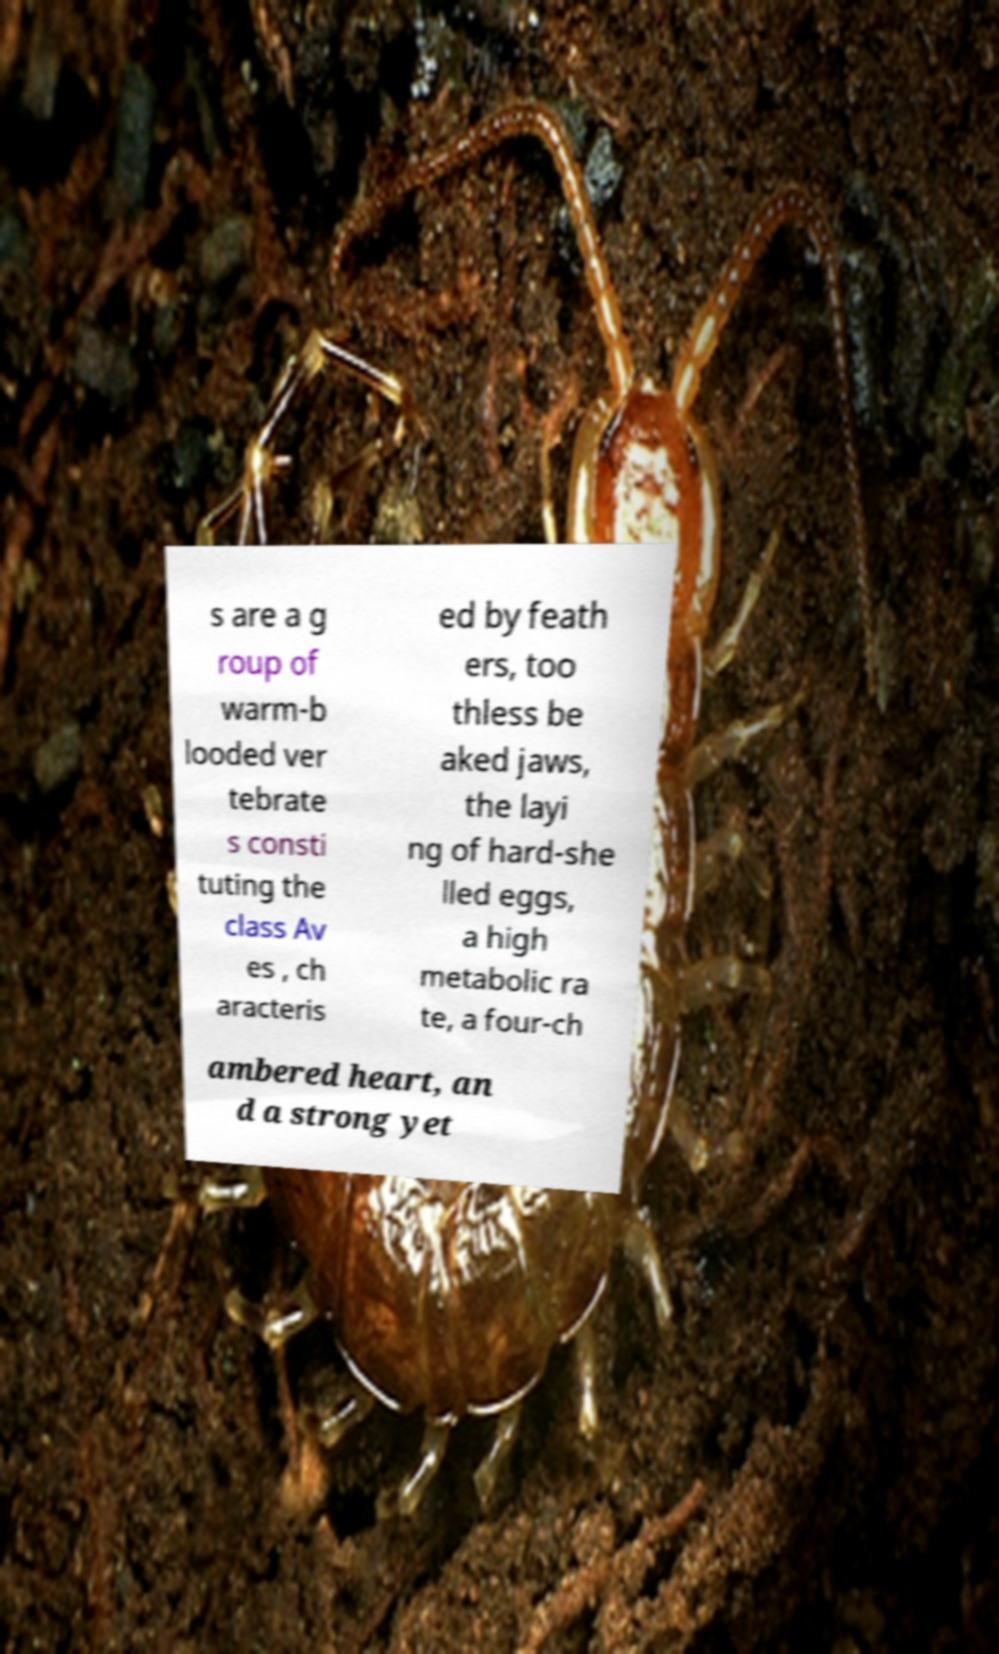Please read and relay the text visible in this image. What does it say? s are a g roup of warm-b looded ver tebrate s consti tuting the class Av es , ch aracteris ed by feath ers, too thless be aked jaws, the layi ng of hard-she lled eggs, a high metabolic ra te, a four-ch ambered heart, an d a strong yet 